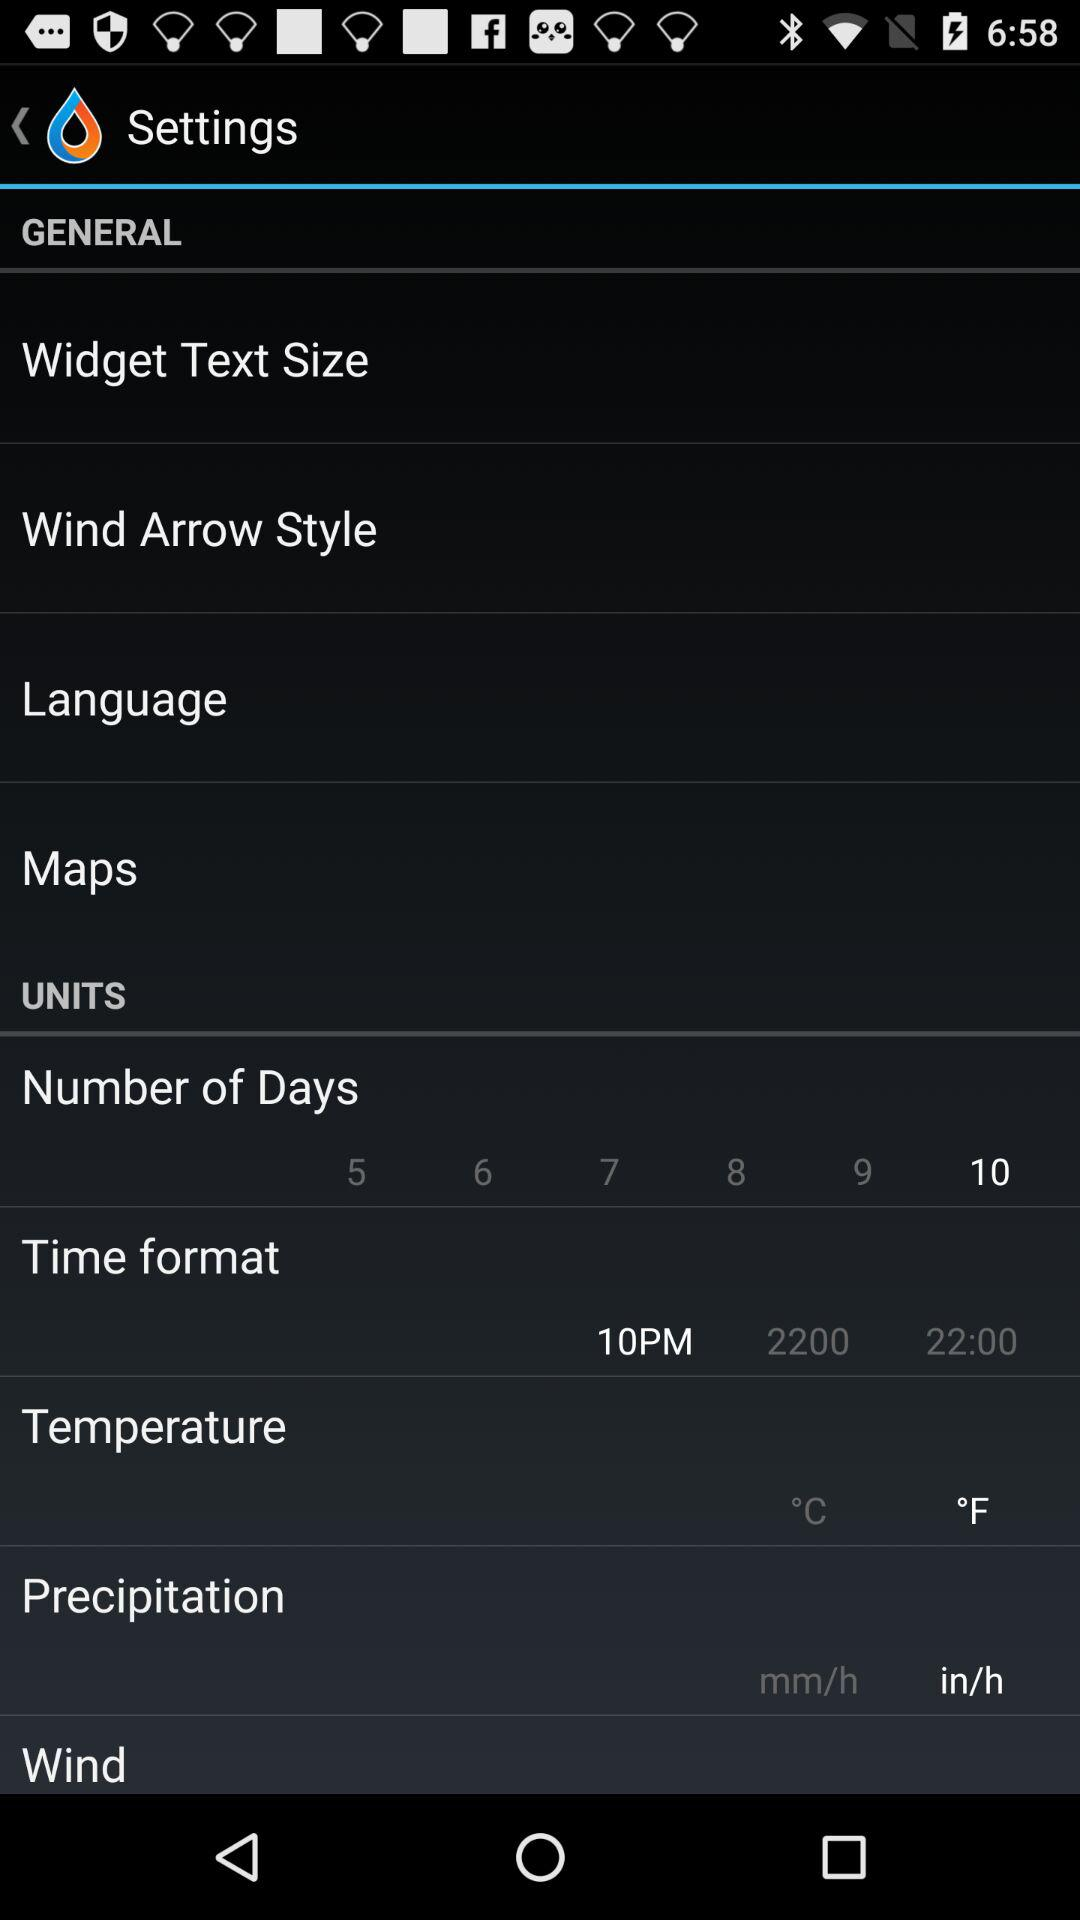How many numbers of days are selected? The number of days is 10. 